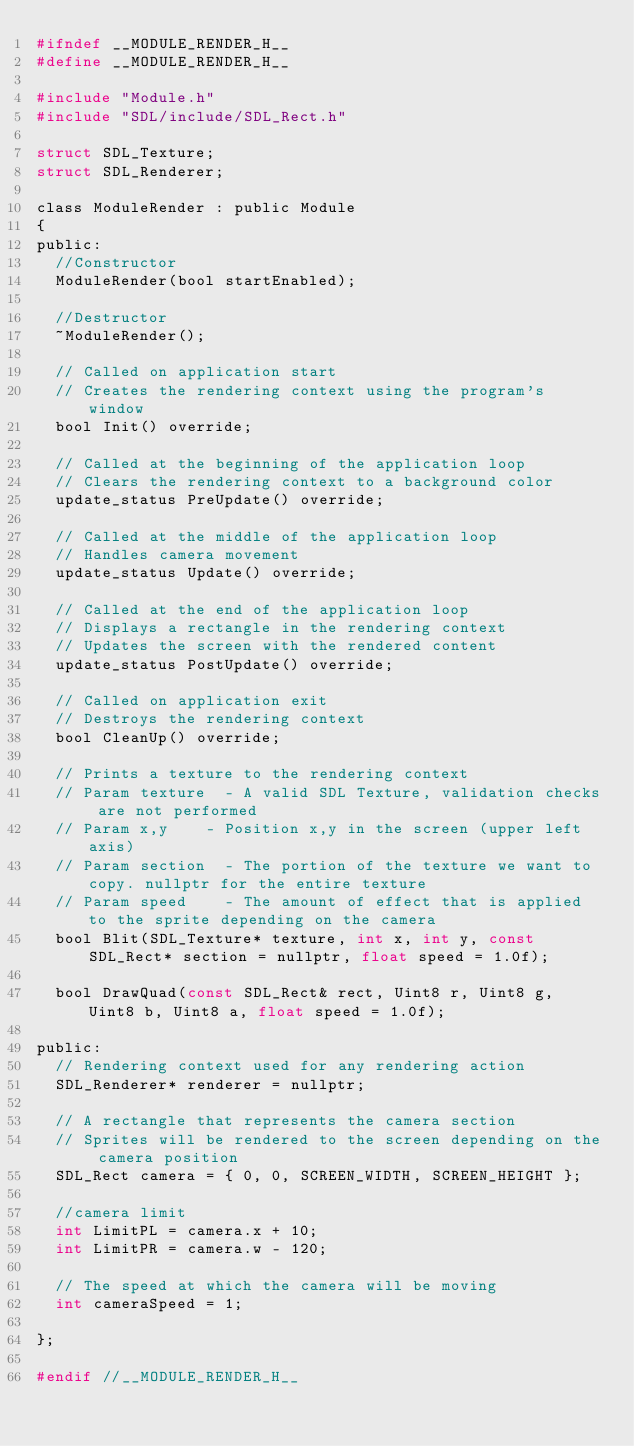<code> <loc_0><loc_0><loc_500><loc_500><_C_>#ifndef __MODULE_RENDER_H__
#define __MODULE_RENDER_H__

#include "Module.h"
#include "SDL/include/SDL_Rect.h"

struct SDL_Texture;
struct SDL_Renderer;

class ModuleRender : public Module
{
public:
	//Constructor
	ModuleRender(bool startEnabled);

	//Destructor
	~ModuleRender();

	// Called on application start
	// Creates the rendering context using the program's window
	bool Init() override;

	// Called at the beginning of the application loop
	// Clears the rendering context to a background color
	update_status PreUpdate() override;

	// Called at the middle of the application loop
	// Handles camera movement
	update_status Update() override;

	// Called at the end of the application loop
	// Displays a rectangle in the rendering context
	// Updates the screen with the rendered content
	update_status PostUpdate() override;

	// Called on application exit
	// Destroys the rendering context
	bool CleanUp() override;

	// Prints a texture to the rendering context
	// Param texture	- A valid SDL Texture, validation checks are not performed
	// Param x,y		- Position x,y in the screen (upper left axis)
	// Param section	- The portion of the texture we want to copy. nullptr for the entire texture
	// Param speed		- The amount of effect that is applied to the sprite depending on the camera
	bool Blit(SDL_Texture* texture, int x, int y, const SDL_Rect* section = nullptr, float speed = 1.0f);

	bool DrawQuad(const SDL_Rect& rect, Uint8 r, Uint8 g, Uint8 b, Uint8 a, float speed = 1.0f);

public:
	// Rendering context used for any rendering action
	SDL_Renderer* renderer = nullptr;

	// A rectangle that represents the camera section
	// Sprites will be rendered to the screen depending on the camera position
	SDL_Rect camera = { 0, 0, SCREEN_WIDTH, SCREEN_HEIGHT };
	
	//camera limit
	int LimitPL = camera.x + 10;
	int LimitPR = camera.w - 120;

	// The speed at which the camera will be moving
	int cameraSpeed = 1;

};

#endif //__MODULE_RENDER_H__
</code> 